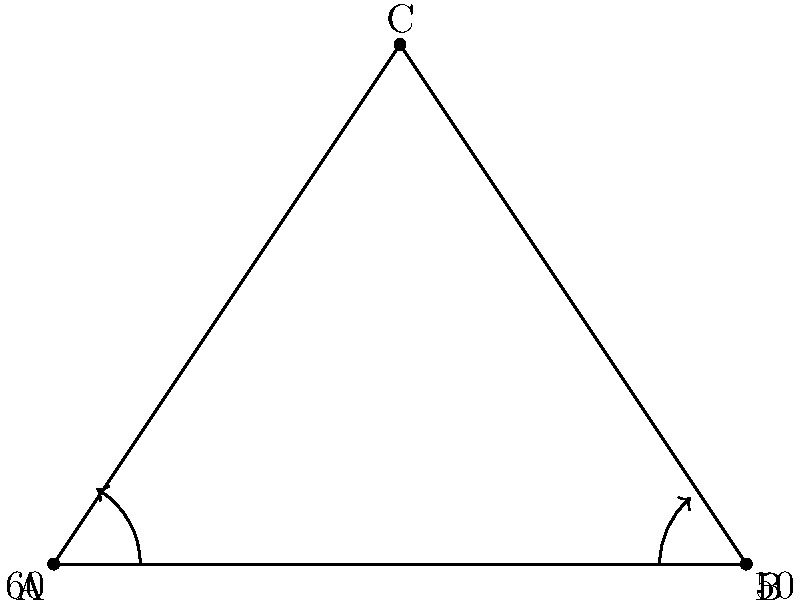As you're setting up the stage for a performance, you notice that three microphone stands form a triangle. The angle between two stands is 60°, and another angle is 50°. What is the measure of the third angle in this microphone stand arrangement? Let's approach this step-by-step:

1) First, recall that the sum of angles in any triangle is always 180°. This is a fundamental property of triangles.

2) We are given two of the three angles in this triangle:
   - One angle is 60°
   - Another angle is 50°

3) Let's call the third angle $x°$.

4) We can set up an equation based on the fact that all three angles must sum to 180°:

   $60° + 50° + x° = 180°$

5) Simplify the left side of the equation:

   $110° + x° = 180°$

6) To solve for $x$, subtract 110° from both sides:

   $x° = 180° - 110°$
   $x° = 70°$

Therefore, the measure of the third angle is 70°.
Answer: 70° 